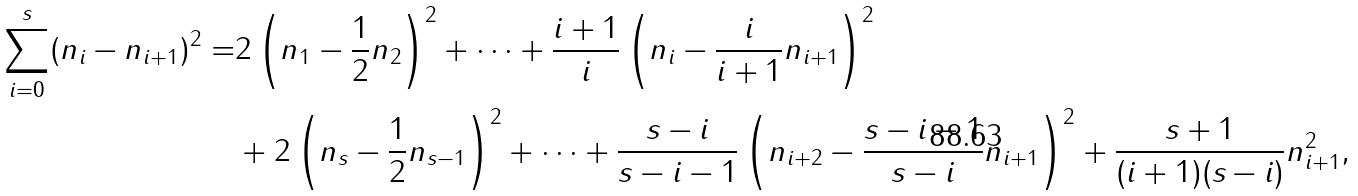<formula> <loc_0><loc_0><loc_500><loc_500>\sum _ { i = 0 } ^ { s } ( n _ { i } - n _ { i + 1 } ) ^ { 2 } = & 2 \left ( n _ { 1 } - \frac { 1 } { 2 } n _ { 2 } \right ) ^ { 2 } + \dots + \frac { i + 1 } { i } \left ( n _ { i } - \frac { i } { i + 1 } n _ { i + 1 } \right ) ^ { 2 } \\ & + 2 \left ( n _ { s } - \frac { 1 } { 2 } n _ { s - 1 } \right ) ^ { 2 } + \dots + \frac { s - i } { s - i - 1 } \left ( n _ { i + 2 } - \frac { s - i - 1 } { s - i } n _ { i + 1 } \right ) ^ { 2 } + \frac { s + 1 } { ( i + 1 ) ( s - i ) } n _ { i + 1 } ^ { 2 } ,</formula> 